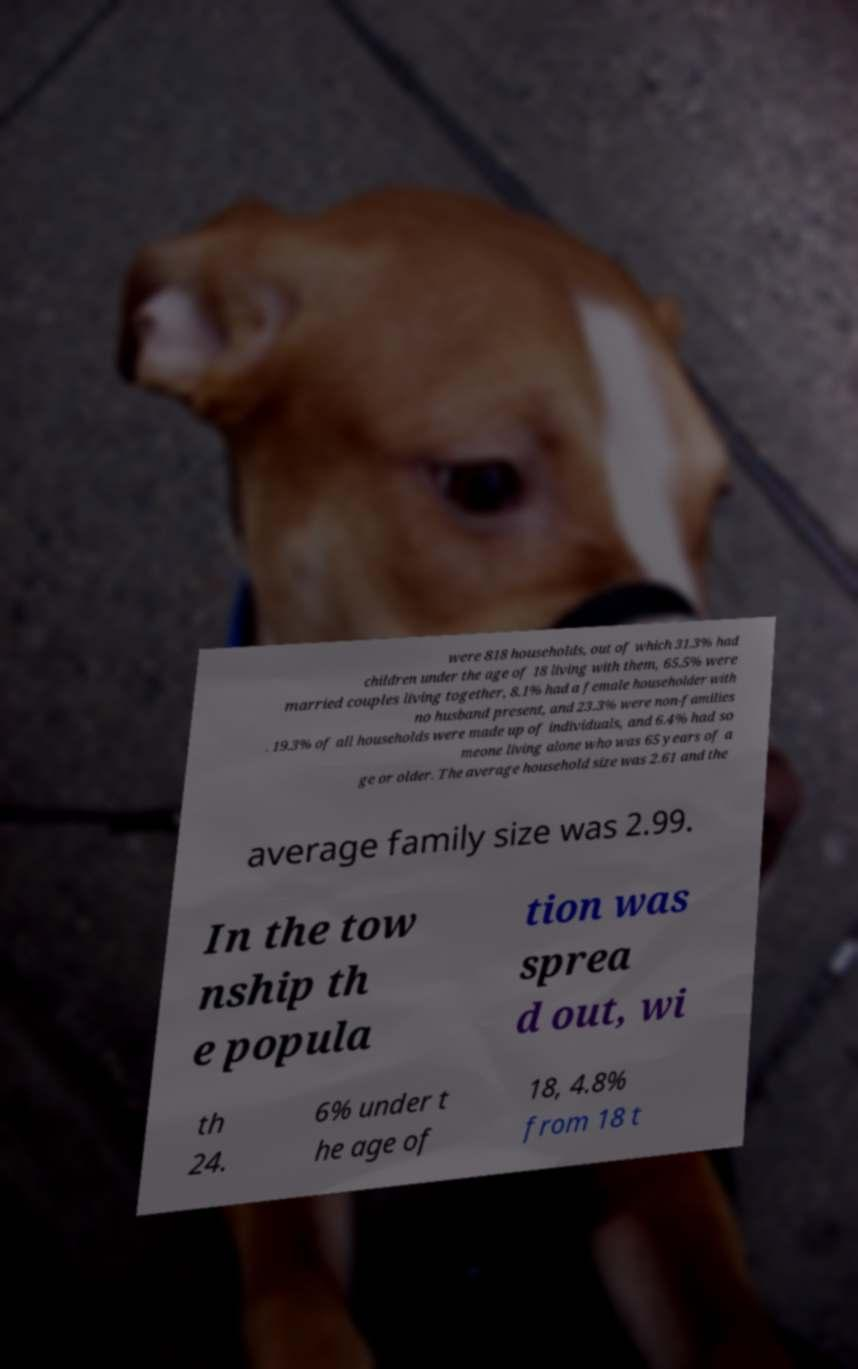Please identify and transcribe the text found in this image. were 818 households, out of which 31.3% had children under the age of 18 living with them, 65.5% were married couples living together, 8.1% had a female householder with no husband present, and 23.3% were non-families . 19.3% of all households were made up of individuals, and 6.4% had so meone living alone who was 65 years of a ge or older. The average household size was 2.61 and the average family size was 2.99. In the tow nship th e popula tion was sprea d out, wi th 24. 6% under t he age of 18, 4.8% from 18 t 